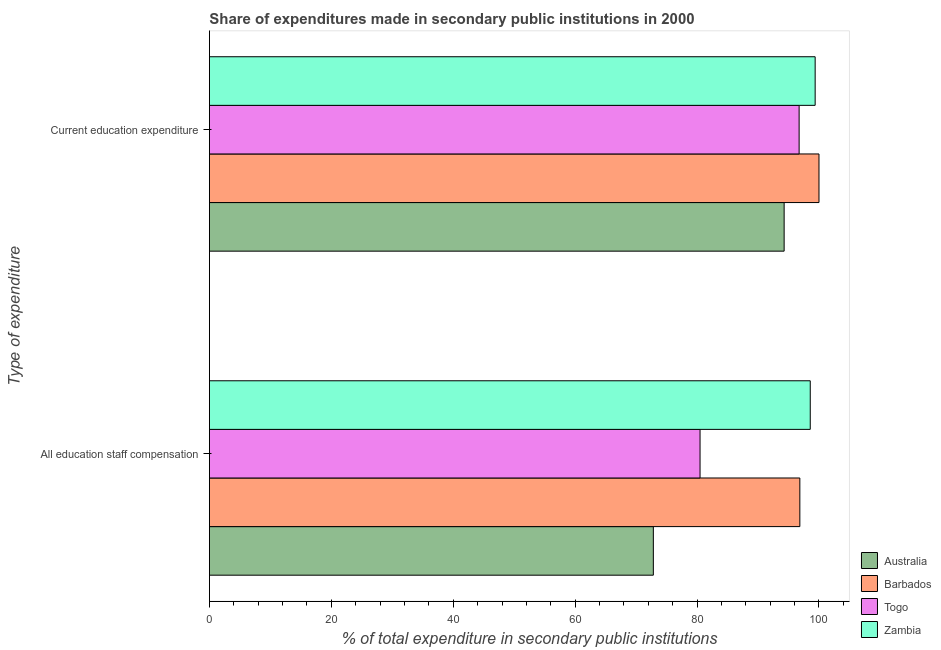How many groups of bars are there?
Offer a very short reply. 2. How many bars are there on the 2nd tick from the top?
Ensure brevity in your answer.  4. What is the label of the 1st group of bars from the top?
Your answer should be very brief. Current education expenditure. What is the expenditure in education in Togo?
Ensure brevity in your answer.  96.74. Across all countries, what is the maximum expenditure in staff compensation?
Provide a succinct answer. 98.57. Across all countries, what is the minimum expenditure in staff compensation?
Ensure brevity in your answer.  72.83. In which country was the expenditure in staff compensation maximum?
Your response must be concise. Zambia. In which country was the expenditure in staff compensation minimum?
Make the answer very short. Australia. What is the total expenditure in staff compensation in the graph?
Your answer should be compact. 348.75. What is the difference between the expenditure in staff compensation in Barbados and that in Zambia?
Make the answer very short. -1.71. What is the difference between the expenditure in education in Australia and the expenditure in staff compensation in Barbados?
Your answer should be very brief. -2.58. What is the average expenditure in education per country?
Provide a succinct answer. 97.6. What is the difference between the expenditure in education and expenditure in staff compensation in Zambia?
Your answer should be compact. 0.8. In how many countries, is the expenditure in education greater than 88 %?
Your answer should be compact. 4. What is the ratio of the expenditure in education in Zambia to that in Barbados?
Provide a short and direct response. 0.99. Is the expenditure in education in Barbados less than that in Togo?
Give a very brief answer. No. What does the 4th bar from the top in Current education expenditure represents?
Make the answer very short. Australia. What does the 2nd bar from the bottom in All education staff compensation represents?
Your answer should be very brief. Barbados. Are all the bars in the graph horizontal?
Your answer should be compact. Yes. What is the difference between two consecutive major ticks on the X-axis?
Ensure brevity in your answer.  20. Does the graph contain grids?
Ensure brevity in your answer.  No. How are the legend labels stacked?
Provide a succinct answer. Vertical. What is the title of the graph?
Give a very brief answer. Share of expenditures made in secondary public institutions in 2000. Does "Micronesia" appear as one of the legend labels in the graph?
Ensure brevity in your answer.  No. What is the label or title of the X-axis?
Offer a terse response. % of total expenditure in secondary public institutions. What is the label or title of the Y-axis?
Make the answer very short. Type of expenditure. What is the % of total expenditure in secondary public institutions in Australia in All education staff compensation?
Your answer should be very brief. 72.83. What is the % of total expenditure in secondary public institutions in Barbados in All education staff compensation?
Your answer should be compact. 96.86. What is the % of total expenditure in secondary public institutions of Togo in All education staff compensation?
Your answer should be compact. 80.49. What is the % of total expenditure in secondary public institutions of Zambia in All education staff compensation?
Provide a succinct answer. 98.57. What is the % of total expenditure in secondary public institutions of Australia in Current education expenditure?
Make the answer very short. 94.28. What is the % of total expenditure in secondary public institutions of Togo in Current education expenditure?
Offer a terse response. 96.74. What is the % of total expenditure in secondary public institutions in Zambia in Current education expenditure?
Give a very brief answer. 99.37. Across all Type of expenditure, what is the maximum % of total expenditure in secondary public institutions of Australia?
Your answer should be very brief. 94.28. Across all Type of expenditure, what is the maximum % of total expenditure in secondary public institutions of Togo?
Your answer should be compact. 96.74. Across all Type of expenditure, what is the maximum % of total expenditure in secondary public institutions in Zambia?
Ensure brevity in your answer.  99.37. Across all Type of expenditure, what is the minimum % of total expenditure in secondary public institutions in Australia?
Ensure brevity in your answer.  72.83. Across all Type of expenditure, what is the minimum % of total expenditure in secondary public institutions of Barbados?
Offer a terse response. 96.86. Across all Type of expenditure, what is the minimum % of total expenditure in secondary public institutions of Togo?
Offer a terse response. 80.49. Across all Type of expenditure, what is the minimum % of total expenditure in secondary public institutions of Zambia?
Your answer should be very brief. 98.57. What is the total % of total expenditure in secondary public institutions of Australia in the graph?
Your response must be concise. 167.11. What is the total % of total expenditure in secondary public institutions of Barbados in the graph?
Offer a very short reply. 196.86. What is the total % of total expenditure in secondary public institutions in Togo in the graph?
Keep it short and to the point. 177.23. What is the total % of total expenditure in secondary public institutions of Zambia in the graph?
Make the answer very short. 197.94. What is the difference between the % of total expenditure in secondary public institutions in Australia in All education staff compensation and that in Current education expenditure?
Provide a short and direct response. -21.46. What is the difference between the % of total expenditure in secondary public institutions of Barbados in All education staff compensation and that in Current education expenditure?
Offer a terse response. -3.14. What is the difference between the % of total expenditure in secondary public institutions of Togo in All education staff compensation and that in Current education expenditure?
Keep it short and to the point. -16.25. What is the difference between the % of total expenditure in secondary public institutions in Zambia in All education staff compensation and that in Current education expenditure?
Offer a terse response. -0.8. What is the difference between the % of total expenditure in secondary public institutions of Australia in All education staff compensation and the % of total expenditure in secondary public institutions of Barbados in Current education expenditure?
Ensure brevity in your answer.  -27.17. What is the difference between the % of total expenditure in secondary public institutions in Australia in All education staff compensation and the % of total expenditure in secondary public institutions in Togo in Current education expenditure?
Offer a terse response. -23.91. What is the difference between the % of total expenditure in secondary public institutions in Australia in All education staff compensation and the % of total expenditure in secondary public institutions in Zambia in Current education expenditure?
Give a very brief answer. -26.55. What is the difference between the % of total expenditure in secondary public institutions in Barbados in All education staff compensation and the % of total expenditure in secondary public institutions in Togo in Current education expenditure?
Make the answer very short. 0.12. What is the difference between the % of total expenditure in secondary public institutions of Barbados in All education staff compensation and the % of total expenditure in secondary public institutions of Zambia in Current education expenditure?
Give a very brief answer. -2.51. What is the difference between the % of total expenditure in secondary public institutions of Togo in All education staff compensation and the % of total expenditure in secondary public institutions of Zambia in Current education expenditure?
Your answer should be very brief. -18.88. What is the average % of total expenditure in secondary public institutions in Australia per Type of expenditure?
Offer a very short reply. 83.56. What is the average % of total expenditure in secondary public institutions of Barbados per Type of expenditure?
Make the answer very short. 98.43. What is the average % of total expenditure in secondary public institutions of Togo per Type of expenditure?
Offer a very short reply. 88.62. What is the average % of total expenditure in secondary public institutions of Zambia per Type of expenditure?
Ensure brevity in your answer.  98.97. What is the difference between the % of total expenditure in secondary public institutions of Australia and % of total expenditure in secondary public institutions of Barbados in All education staff compensation?
Keep it short and to the point. -24.03. What is the difference between the % of total expenditure in secondary public institutions of Australia and % of total expenditure in secondary public institutions of Togo in All education staff compensation?
Give a very brief answer. -7.66. What is the difference between the % of total expenditure in secondary public institutions of Australia and % of total expenditure in secondary public institutions of Zambia in All education staff compensation?
Give a very brief answer. -25.74. What is the difference between the % of total expenditure in secondary public institutions in Barbados and % of total expenditure in secondary public institutions in Togo in All education staff compensation?
Provide a short and direct response. 16.37. What is the difference between the % of total expenditure in secondary public institutions of Barbados and % of total expenditure in secondary public institutions of Zambia in All education staff compensation?
Offer a terse response. -1.71. What is the difference between the % of total expenditure in secondary public institutions in Togo and % of total expenditure in secondary public institutions in Zambia in All education staff compensation?
Provide a short and direct response. -18.08. What is the difference between the % of total expenditure in secondary public institutions in Australia and % of total expenditure in secondary public institutions in Barbados in Current education expenditure?
Provide a succinct answer. -5.72. What is the difference between the % of total expenditure in secondary public institutions in Australia and % of total expenditure in secondary public institutions in Togo in Current education expenditure?
Ensure brevity in your answer.  -2.46. What is the difference between the % of total expenditure in secondary public institutions in Australia and % of total expenditure in secondary public institutions in Zambia in Current education expenditure?
Keep it short and to the point. -5.09. What is the difference between the % of total expenditure in secondary public institutions in Barbados and % of total expenditure in secondary public institutions in Togo in Current education expenditure?
Offer a terse response. 3.26. What is the difference between the % of total expenditure in secondary public institutions in Barbados and % of total expenditure in secondary public institutions in Zambia in Current education expenditure?
Your response must be concise. 0.63. What is the difference between the % of total expenditure in secondary public institutions of Togo and % of total expenditure in secondary public institutions of Zambia in Current education expenditure?
Keep it short and to the point. -2.63. What is the ratio of the % of total expenditure in secondary public institutions of Australia in All education staff compensation to that in Current education expenditure?
Your answer should be compact. 0.77. What is the ratio of the % of total expenditure in secondary public institutions in Barbados in All education staff compensation to that in Current education expenditure?
Provide a short and direct response. 0.97. What is the ratio of the % of total expenditure in secondary public institutions of Togo in All education staff compensation to that in Current education expenditure?
Provide a short and direct response. 0.83. What is the ratio of the % of total expenditure in secondary public institutions in Zambia in All education staff compensation to that in Current education expenditure?
Ensure brevity in your answer.  0.99. What is the difference between the highest and the second highest % of total expenditure in secondary public institutions of Australia?
Keep it short and to the point. 21.46. What is the difference between the highest and the second highest % of total expenditure in secondary public institutions of Barbados?
Your response must be concise. 3.14. What is the difference between the highest and the second highest % of total expenditure in secondary public institutions in Togo?
Your response must be concise. 16.25. What is the difference between the highest and the second highest % of total expenditure in secondary public institutions of Zambia?
Offer a terse response. 0.8. What is the difference between the highest and the lowest % of total expenditure in secondary public institutions in Australia?
Your answer should be very brief. 21.46. What is the difference between the highest and the lowest % of total expenditure in secondary public institutions in Barbados?
Your answer should be very brief. 3.14. What is the difference between the highest and the lowest % of total expenditure in secondary public institutions of Togo?
Give a very brief answer. 16.25. What is the difference between the highest and the lowest % of total expenditure in secondary public institutions of Zambia?
Ensure brevity in your answer.  0.8. 